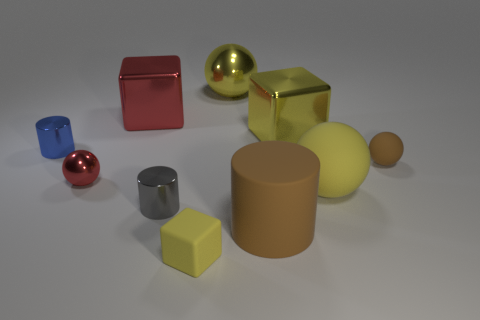Subtract all shiny blocks. How many blocks are left? 1 Subtract all red blocks. How many blocks are left? 2 Subtract 2 spheres. How many spheres are left? 2 Subtract all cylinders. How many objects are left? 7 Subtract all cyan cylinders. How many brown spheres are left? 1 Subtract all tiny gray cylinders. Subtract all yellow objects. How many objects are left? 5 Add 6 large matte objects. How many large matte objects are left? 8 Add 9 small brown matte cubes. How many small brown matte cubes exist? 9 Subtract 0 green cylinders. How many objects are left? 10 Subtract all gray balls. Subtract all yellow blocks. How many balls are left? 4 